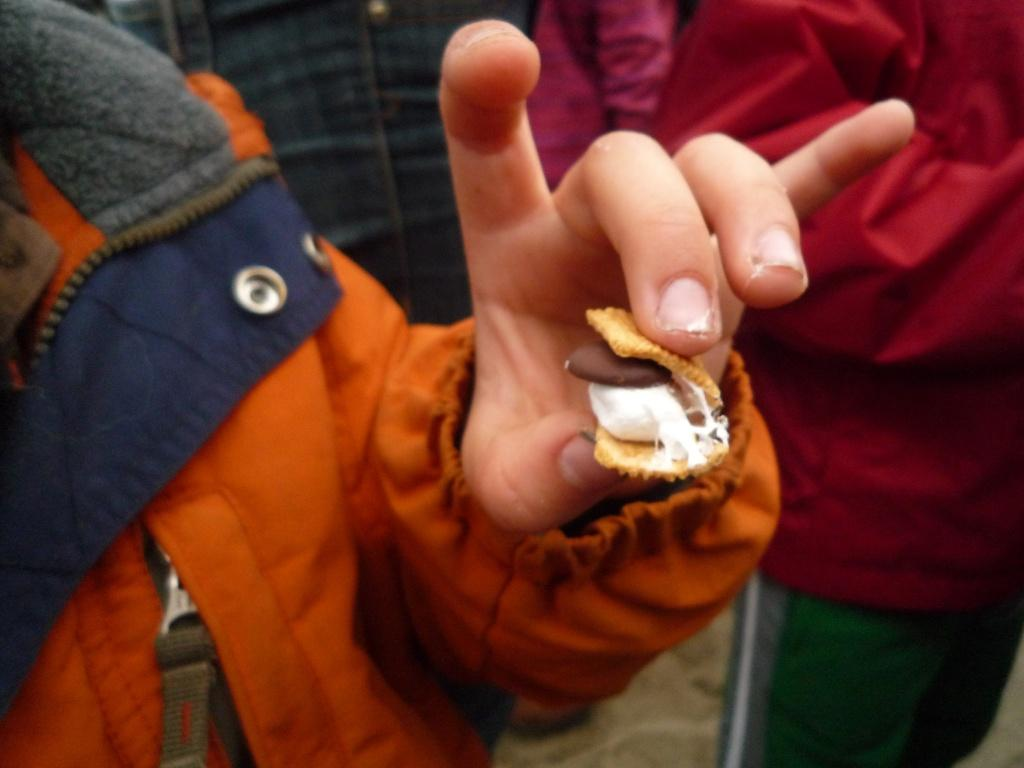What is the main subject of the image? There is a person in the image. What is the person holding in the image? The person is holding a food item. Are there any other people present in the image? Yes, there are other people present in the image. Can you tell me the route the person is taking with their underwear in the image? There is no underwear present in the image, and therefore no route can be determined. 